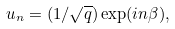Convert formula to latex. <formula><loc_0><loc_0><loc_500><loc_500>u _ { n } = ( 1 / \sqrt { q } ) \exp ( i n \beta ) ,</formula> 